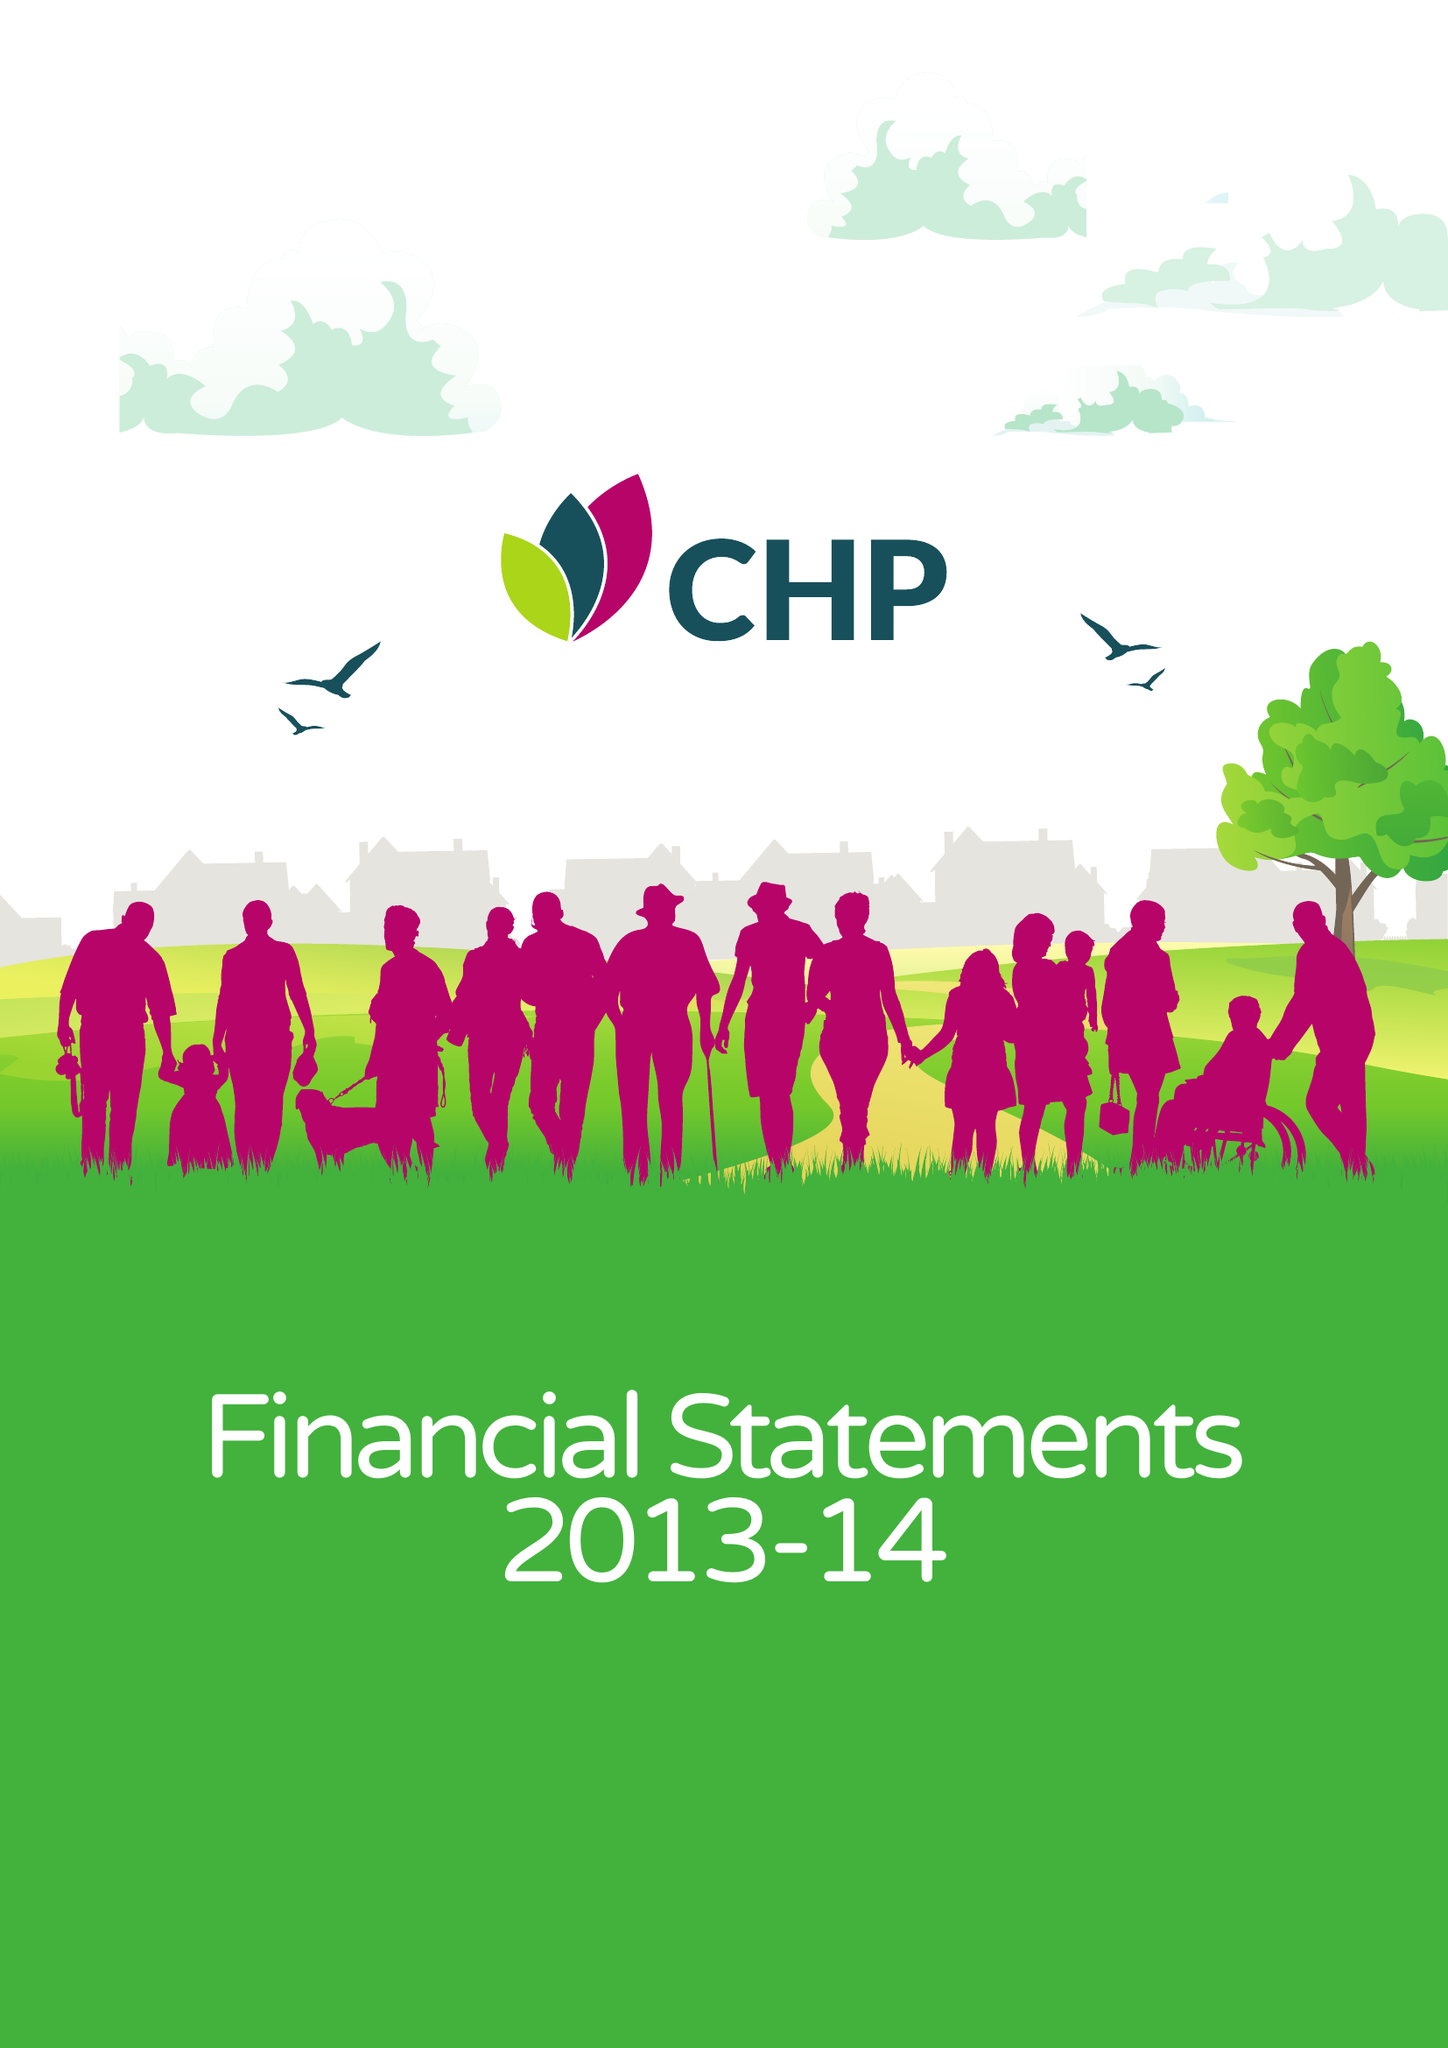What is the value for the charity_name?
Answer the question using a single word or phrase. Chelmer Housing Partnership Ltd. 